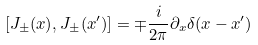<formula> <loc_0><loc_0><loc_500><loc_500>[ J _ { \pm } ( x ) , J _ { \pm } ( x ^ { \prime } ) ] = \mp \frac { i } { 2 \pi } \partial _ { x } \delta ( x - x ^ { \prime } )</formula> 